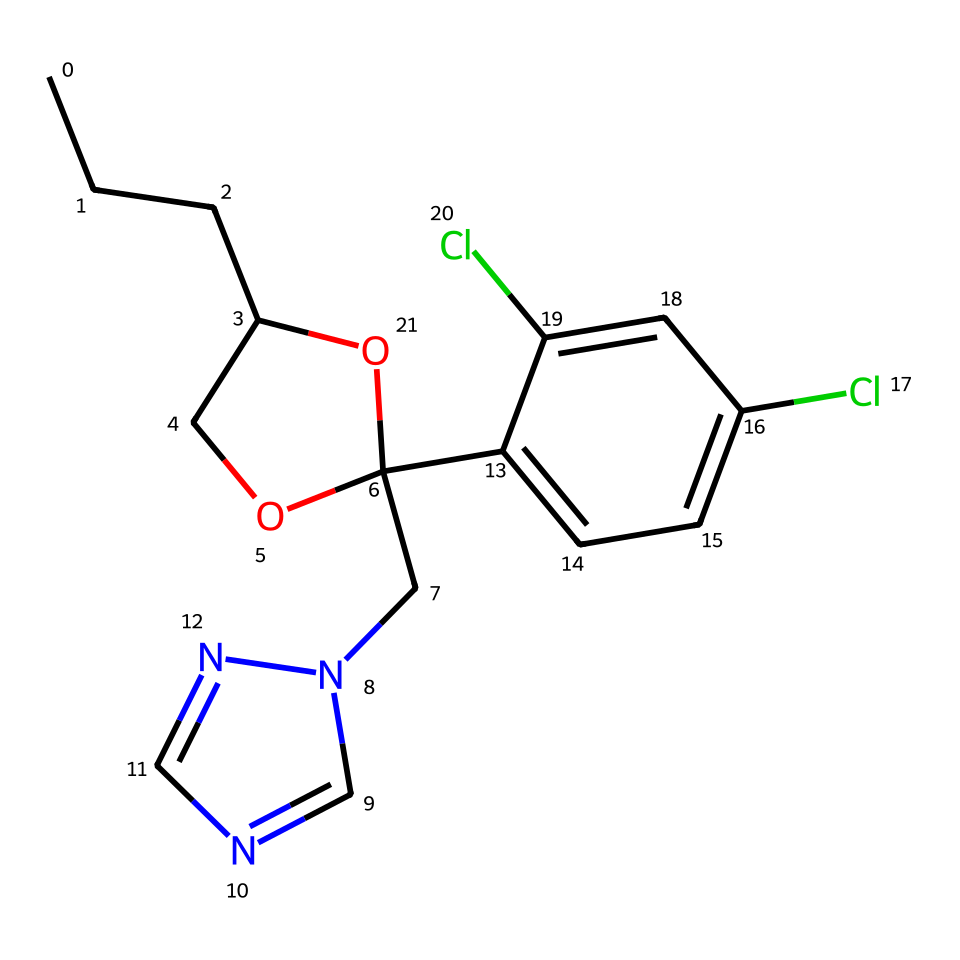What is the molecular formula of propiconazole? To determine the molecular formula, count the number of each type of atom represented in the SMILES structure. The count shows there are 17 carbon (C) atoms, 20 hydrogen (H) atoms, 2 chlorine (Cl) atoms, 2 nitrogen (N) atoms, and 2 oxygen (O) atoms. Therefore, the molecular formula is C17H20Cl2N2O2.
Answer: C17H20Cl2N2O2 How many rings are present in the chemical structure? Looking closely at the SMILES representation, there are two cyclic components present in the structure: one is a five-membered ring (the oxygen containing part), and the other is a benzene ring. This counts to a total of two rings.
Answer: 2 What type of functional groups are present in propiconazole? By analyzing the structure, the functional groups identifiable include a hydroxyl group (-OH) and an ether group (-O-). These groups are key to the chemical’s reactivity and properties.
Answer: hydroxyl and ether Which element contributes to the fungicidal activity in propiconazole? The nitrogen atoms in the chemical structure are crucial for the fungicidal activity. These atoms are often involved in the interaction with fungal cells, disrupting their functions and leading to their death.
Answer: nitrogen How does chlorination affect propiconazole’s fungicidal properties? The presence of chlorine atoms in propiconazole enhances its chemical stability and increases its hydrophobicity, which can improve its absorption and retention in plant tissues, ultimately enhancing its fungicidal efficacy.
Answer: increases stability and efficacy What is the significance of the carbon chain length in the chemical structure? The length of the carbon chain affects the lipophilicity of the compound; a longer carbon chain typically increases the ability to penetrate cellular membranes, which is important for the systemic action of propiconazole.
Answer: increases lipophilicity 